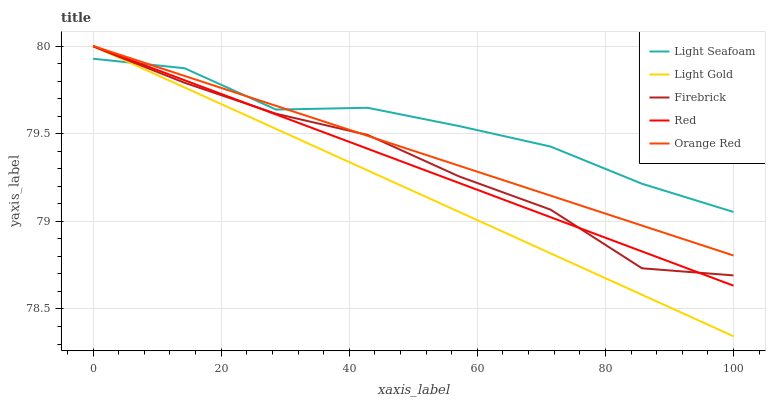Does Light Seafoam have the minimum area under the curve?
Answer yes or no. No. Does Light Gold have the maximum area under the curve?
Answer yes or no. No. Is Light Gold the smoothest?
Answer yes or no. No. Is Light Gold the roughest?
Answer yes or no. No. Does Light Seafoam have the lowest value?
Answer yes or no. No. Does Light Seafoam have the highest value?
Answer yes or no. No. 